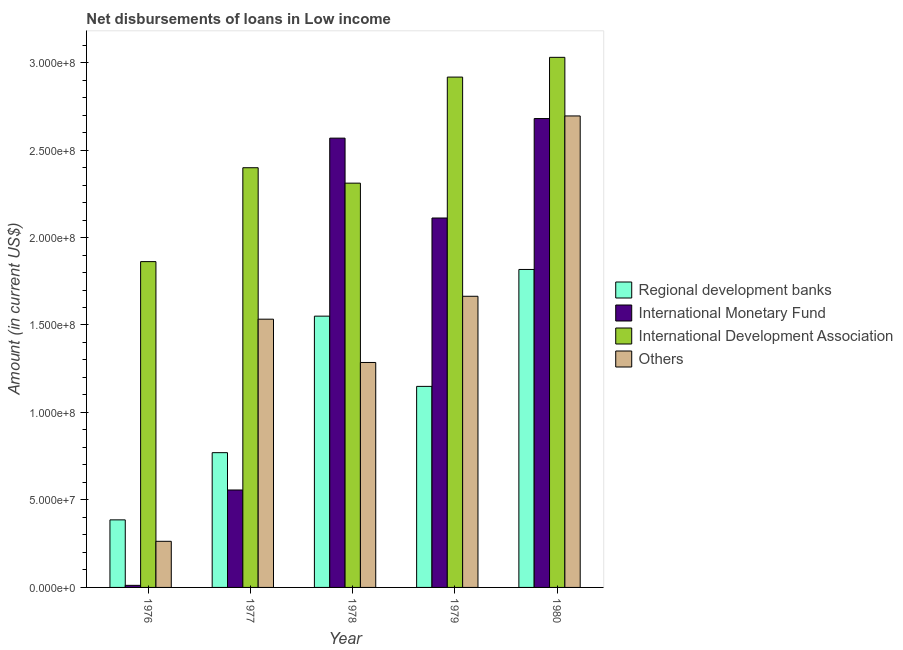How many different coloured bars are there?
Provide a short and direct response. 4. How many groups of bars are there?
Provide a short and direct response. 5. How many bars are there on the 3rd tick from the left?
Provide a short and direct response. 4. What is the label of the 3rd group of bars from the left?
Your answer should be compact. 1978. What is the amount of loan disimbursed by regional development banks in 1980?
Your answer should be compact. 1.82e+08. Across all years, what is the maximum amount of loan disimbursed by other organisations?
Give a very brief answer. 2.69e+08. Across all years, what is the minimum amount of loan disimbursed by international monetary fund?
Give a very brief answer. 1.18e+06. In which year was the amount of loan disimbursed by other organisations minimum?
Provide a succinct answer. 1976. What is the total amount of loan disimbursed by international development association in the graph?
Ensure brevity in your answer.  1.25e+09. What is the difference between the amount of loan disimbursed by international development association in 1976 and that in 1980?
Make the answer very short. -1.17e+08. What is the difference between the amount of loan disimbursed by other organisations in 1976 and the amount of loan disimbursed by international development association in 1977?
Keep it short and to the point. -1.27e+08. What is the average amount of loan disimbursed by regional development banks per year?
Provide a short and direct response. 1.13e+08. What is the ratio of the amount of loan disimbursed by international monetary fund in 1976 to that in 1977?
Give a very brief answer. 0.02. Is the amount of loan disimbursed by other organisations in 1976 less than that in 1979?
Keep it short and to the point. Yes. Is the difference between the amount of loan disimbursed by international monetary fund in 1979 and 1980 greater than the difference between the amount of loan disimbursed by other organisations in 1979 and 1980?
Provide a short and direct response. No. What is the difference between the highest and the second highest amount of loan disimbursed by other organisations?
Provide a succinct answer. 1.03e+08. What is the difference between the highest and the lowest amount of loan disimbursed by other organisations?
Make the answer very short. 2.43e+08. Is the sum of the amount of loan disimbursed by international development association in 1979 and 1980 greater than the maximum amount of loan disimbursed by other organisations across all years?
Your answer should be compact. Yes. What does the 3rd bar from the left in 1976 represents?
Your answer should be compact. International Development Association. What does the 4th bar from the right in 1976 represents?
Your answer should be very brief. Regional development banks. Is it the case that in every year, the sum of the amount of loan disimbursed by regional development banks and amount of loan disimbursed by international monetary fund is greater than the amount of loan disimbursed by international development association?
Make the answer very short. No. How many bars are there?
Provide a short and direct response. 20. Are all the bars in the graph horizontal?
Provide a succinct answer. No. Are the values on the major ticks of Y-axis written in scientific E-notation?
Provide a short and direct response. Yes. How many legend labels are there?
Keep it short and to the point. 4. How are the legend labels stacked?
Make the answer very short. Vertical. What is the title of the graph?
Your answer should be compact. Net disbursements of loans in Low income. Does "Gender equality" appear as one of the legend labels in the graph?
Your answer should be compact. No. What is the label or title of the X-axis?
Your answer should be compact. Year. What is the label or title of the Y-axis?
Your answer should be compact. Amount (in current US$). What is the Amount (in current US$) of Regional development banks in 1976?
Your answer should be compact. 3.86e+07. What is the Amount (in current US$) in International Monetary Fund in 1976?
Offer a terse response. 1.18e+06. What is the Amount (in current US$) of International Development Association in 1976?
Offer a very short reply. 1.86e+08. What is the Amount (in current US$) of Others in 1976?
Provide a short and direct response. 2.64e+07. What is the Amount (in current US$) of Regional development banks in 1977?
Ensure brevity in your answer.  7.70e+07. What is the Amount (in current US$) in International Monetary Fund in 1977?
Your answer should be compact. 5.57e+07. What is the Amount (in current US$) of International Development Association in 1977?
Give a very brief answer. 2.40e+08. What is the Amount (in current US$) in Others in 1977?
Make the answer very short. 1.53e+08. What is the Amount (in current US$) of Regional development banks in 1978?
Provide a short and direct response. 1.55e+08. What is the Amount (in current US$) in International Monetary Fund in 1978?
Offer a very short reply. 2.57e+08. What is the Amount (in current US$) in International Development Association in 1978?
Offer a terse response. 2.31e+08. What is the Amount (in current US$) of Others in 1978?
Provide a succinct answer. 1.29e+08. What is the Amount (in current US$) in Regional development banks in 1979?
Your answer should be very brief. 1.15e+08. What is the Amount (in current US$) of International Monetary Fund in 1979?
Your answer should be compact. 2.11e+08. What is the Amount (in current US$) of International Development Association in 1979?
Ensure brevity in your answer.  2.92e+08. What is the Amount (in current US$) in Others in 1979?
Your response must be concise. 1.66e+08. What is the Amount (in current US$) in Regional development banks in 1980?
Your answer should be compact. 1.82e+08. What is the Amount (in current US$) in International Monetary Fund in 1980?
Ensure brevity in your answer.  2.68e+08. What is the Amount (in current US$) in International Development Association in 1980?
Ensure brevity in your answer.  3.03e+08. What is the Amount (in current US$) in Others in 1980?
Offer a terse response. 2.69e+08. Across all years, what is the maximum Amount (in current US$) of Regional development banks?
Keep it short and to the point. 1.82e+08. Across all years, what is the maximum Amount (in current US$) of International Monetary Fund?
Give a very brief answer. 2.68e+08. Across all years, what is the maximum Amount (in current US$) in International Development Association?
Offer a terse response. 3.03e+08. Across all years, what is the maximum Amount (in current US$) in Others?
Your answer should be compact. 2.69e+08. Across all years, what is the minimum Amount (in current US$) of Regional development banks?
Offer a very short reply. 3.86e+07. Across all years, what is the minimum Amount (in current US$) of International Monetary Fund?
Provide a succinct answer. 1.18e+06. Across all years, what is the minimum Amount (in current US$) in International Development Association?
Make the answer very short. 1.86e+08. Across all years, what is the minimum Amount (in current US$) in Others?
Provide a short and direct response. 2.64e+07. What is the total Amount (in current US$) in Regional development banks in the graph?
Provide a short and direct response. 5.67e+08. What is the total Amount (in current US$) of International Monetary Fund in the graph?
Make the answer very short. 7.93e+08. What is the total Amount (in current US$) of International Development Association in the graph?
Offer a terse response. 1.25e+09. What is the total Amount (in current US$) in Others in the graph?
Make the answer very short. 7.44e+08. What is the difference between the Amount (in current US$) of Regional development banks in 1976 and that in 1977?
Make the answer very short. -3.84e+07. What is the difference between the Amount (in current US$) in International Monetary Fund in 1976 and that in 1977?
Ensure brevity in your answer.  -5.45e+07. What is the difference between the Amount (in current US$) in International Development Association in 1976 and that in 1977?
Ensure brevity in your answer.  -5.37e+07. What is the difference between the Amount (in current US$) in Others in 1976 and that in 1977?
Provide a succinct answer. -1.27e+08. What is the difference between the Amount (in current US$) in Regional development banks in 1976 and that in 1978?
Provide a short and direct response. -1.16e+08. What is the difference between the Amount (in current US$) of International Monetary Fund in 1976 and that in 1978?
Your answer should be compact. -2.56e+08. What is the difference between the Amount (in current US$) in International Development Association in 1976 and that in 1978?
Keep it short and to the point. -4.48e+07. What is the difference between the Amount (in current US$) of Others in 1976 and that in 1978?
Offer a terse response. -1.02e+08. What is the difference between the Amount (in current US$) in Regional development banks in 1976 and that in 1979?
Provide a short and direct response. -7.63e+07. What is the difference between the Amount (in current US$) in International Monetary Fund in 1976 and that in 1979?
Offer a very short reply. -2.10e+08. What is the difference between the Amount (in current US$) of International Development Association in 1976 and that in 1979?
Offer a terse response. -1.05e+08. What is the difference between the Amount (in current US$) of Others in 1976 and that in 1979?
Ensure brevity in your answer.  -1.40e+08. What is the difference between the Amount (in current US$) in Regional development banks in 1976 and that in 1980?
Ensure brevity in your answer.  -1.43e+08. What is the difference between the Amount (in current US$) of International Monetary Fund in 1976 and that in 1980?
Your answer should be compact. -2.67e+08. What is the difference between the Amount (in current US$) in International Development Association in 1976 and that in 1980?
Keep it short and to the point. -1.17e+08. What is the difference between the Amount (in current US$) in Others in 1976 and that in 1980?
Your response must be concise. -2.43e+08. What is the difference between the Amount (in current US$) of Regional development banks in 1977 and that in 1978?
Ensure brevity in your answer.  -7.80e+07. What is the difference between the Amount (in current US$) in International Monetary Fund in 1977 and that in 1978?
Provide a short and direct response. -2.01e+08. What is the difference between the Amount (in current US$) of International Development Association in 1977 and that in 1978?
Provide a short and direct response. 8.82e+06. What is the difference between the Amount (in current US$) in Others in 1977 and that in 1978?
Offer a very short reply. 2.47e+07. What is the difference between the Amount (in current US$) in Regional development banks in 1977 and that in 1979?
Give a very brief answer. -3.79e+07. What is the difference between the Amount (in current US$) in International Monetary Fund in 1977 and that in 1979?
Offer a very short reply. -1.55e+08. What is the difference between the Amount (in current US$) in International Development Association in 1977 and that in 1979?
Give a very brief answer. -5.18e+07. What is the difference between the Amount (in current US$) of Others in 1977 and that in 1979?
Your answer should be very brief. -1.31e+07. What is the difference between the Amount (in current US$) in Regional development banks in 1977 and that in 1980?
Offer a very short reply. -1.05e+08. What is the difference between the Amount (in current US$) of International Monetary Fund in 1977 and that in 1980?
Provide a succinct answer. -2.12e+08. What is the difference between the Amount (in current US$) of International Development Association in 1977 and that in 1980?
Offer a very short reply. -6.31e+07. What is the difference between the Amount (in current US$) in Others in 1977 and that in 1980?
Make the answer very short. -1.16e+08. What is the difference between the Amount (in current US$) of Regional development banks in 1978 and that in 1979?
Keep it short and to the point. 4.02e+07. What is the difference between the Amount (in current US$) in International Monetary Fund in 1978 and that in 1979?
Provide a succinct answer. 4.57e+07. What is the difference between the Amount (in current US$) in International Development Association in 1978 and that in 1979?
Give a very brief answer. -6.06e+07. What is the difference between the Amount (in current US$) in Others in 1978 and that in 1979?
Provide a succinct answer. -3.78e+07. What is the difference between the Amount (in current US$) in Regional development banks in 1978 and that in 1980?
Provide a succinct answer. -2.67e+07. What is the difference between the Amount (in current US$) of International Monetary Fund in 1978 and that in 1980?
Provide a short and direct response. -1.12e+07. What is the difference between the Amount (in current US$) in International Development Association in 1978 and that in 1980?
Make the answer very short. -7.19e+07. What is the difference between the Amount (in current US$) of Others in 1978 and that in 1980?
Offer a very short reply. -1.41e+08. What is the difference between the Amount (in current US$) of Regional development banks in 1979 and that in 1980?
Provide a succinct answer. -6.68e+07. What is the difference between the Amount (in current US$) in International Monetary Fund in 1979 and that in 1980?
Give a very brief answer. -5.68e+07. What is the difference between the Amount (in current US$) in International Development Association in 1979 and that in 1980?
Ensure brevity in your answer.  -1.13e+07. What is the difference between the Amount (in current US$) of Others in 1979 and that in 1980?
Your answer should be compact. -1.03e+08. What is the difference between the Amount (in current US$) in Regional development banks in 1976 and the Amount (in current US$) in International Monetary Fund in 1977?
Your answer should be very brief. -1.71e+07. What is the difference between the Amount (in current US$) in Regional development banks in 1976 and the Amount (in current US$) in International Development Association in 1977?
Provide a short and direct response. -2.01e+08. What is the difference between the Amount (in current US$) of Regional development banks in 1976 and the Amount (in current US$) of Others in 1977?
Provide a short and direct response. -1.15e+08. What is the difference between the Amount (in current US$) of International Monetary Fund in 1976 and the Amount (in current US$) of International Development Association in 1977?
Your response must be concise. -2.39e+08. What is the difference between the Amount (in current US$) of International Monetary Fund in 1976 and the Amount (in current US$) of Others in 1977?
Provide a succinct answer. -1.52e+08. What is the difference between the Amount (in current US$) in International Development Association in 1976 and the Amount (in current US$) in Others in 1977?
Keep it short and to the point. 3.29e+07. What is the difference between the Amount (in current US$) of Regional development banks in 1976 and the Amount (in current US$) of International Monetary Fund in 1978?
Offer a terse response. -2.18e+08. What is the difference between the Amount (in current US$) of Regional development banks in 1976 and the Amount (in current US$) of International Development Association in 1978?
Ensure brevity in your answer.  -1.92e+08. What is the difference between the Amount (in current US$) of Regional development banks in 1976 and the Amount (in current US$) of Others in 1978?
Offer a terse response. -9.00e+07. What is the difference between the Amount (in current US$) of International Monetary Fund in 1976 and the Amount (in current US$) of International Development Association in 1978?
Provide a short and direct response. -2.30e+08. What is the difference between the Amount (in current US$) of International Monetary Fund in 1976 and the Amount (in current US$) of Others in 1978?
Give a very brief answer. -1.27e+08. What is the difference between the Amount (in current US$) in International Development Association in 1976 and the Amount (in current US$) in Others in 1978?
Your answer should be compact. 5.76e+07. What is the difference between the Amount (in current US$) in Regional development banks in 1976 and the Amount (in current US$) in International Monetary Fund in 1979?
Your answer should be compact. -1.73e+08. What is the difference between the Amount (in current US$) in Regional development banks in 1976 and the Amount (in current US$) in International Development Association in 1979?
Provide a succinct answer. -2.53e+08. What is the difference between the Amount (in current US$) in Regional development banks in 1976 and the Amount (in current US$) in Others in 1979?
Keep it short and to the point. -1.28e+08. What is the difference between the Amount (in current US$) of International Monetary Fund in 1976 and the Amount (in current US$) of International Development Association in 1979?
Your answer should be compact. -2.91e+08. What is the difference between the Amount (in current US$) in International Monetary Fund in 1976 and the Amount (in current US$) in Others in 1979?
Offer a very short reply. -1.65e+08. What is the difference between the Amount (in current US$) in International Development Association in 1976 and the Amount (in current US$) in Others in 1979?
Provide a short and direct response. 1.98e+07. What is the difference between the Amount (in current US$) in Regional development banks in 1976 and the Amount (in current US$) in International Monetary Fund in 1980?
Provide a succinct answer. -2.29e+08. What is the difference between the Amount (in current US$) of Regional development banks in 1976 and the Amount (in current US$) of International Development Association in 1980?
Provide a short and direct response. -2.64e+08. What is the difference between the Amount (in current US$) of Regional development banks in 1976 and the Amount (in current US$) of Others in 1980?
Your response must be concise. -2.31e+08. What is the difference between the Amount (in current US$) in International Monetary Fund in 1976 and the Amount (in current US$) in International Development Association in 1980?
Keep it short and to the point. -3.02e+08. What is the difference between the Amount (in current US$) of International Monetary Fund in 1976 and the Amount (in current US$) of Others in 1980?
Your response must be concise. -2.68e+08. What is the difference between the Amount (in current US$) of International Development Association in 1976 and the Amount (in current US$) of Others in 1980?
Your response must be concise. -8.33e+07. What is the difference between the Amount (in current US$) in Regional development banks in 1977 and the Amount (in current US$) in International Monetary Fund in 1978?
Offer a very short reply. -1.80e+08. What is the difference between the Amount (in current US$) in Regional development banks in 1977 and the Amount (in current US$) in International Development Association in 1978?
Offer a very short reply. -1.54e+08. What is the difference between the Amount (in current US$) of Regional development banks in 1977 and the Amount (in current US$) of Others in 1978?
Provide a short and direct response. -5.16e+07. What is the difference between the Amount (in current US$) in International Monetary Fund in 1977 and the Amount (in current US$) in International Development Association in 1978?
Offer a terse response. -1.75e+08. What is the difference between the Amount (in current US$) of International Monetary Fund in 1977 and the Amount (in current US$) of Others in 1978?
Your answer should be very brief. -7.29e+07. What is the difference between the Amount (in current US$) of International Development Association in 1977 and the Amount (in current US$) of Others in 1978?
Offer a very short reply. 1.11e+08. What is the difference between the Amount (in current US$) of Regional development banks in 1977 and the Amount (in current US$) of International Monetary Fund in 1979?
Keep it short and to the point. -1.34e+08. What is the difference between the Amount (in current US$) in Regional development banks in 1977 and the Amount (in current US$) in International Development Association in 1979?
Your response must be concise. -2.15e+08. What is the difference between the Amount (in current US$) of Regional development banks in 1977 and the Amount (in current US$) of Others in 1979?
Your response must be concise. -8.94e+07. What is the difference between the Amount (in current US$) of International Monetary Fund in 1977 and the Amount (in current US$) of International Development Association in 1979?
Offer a terse response. -2.36e+08. What is the difference between the Amount (in current US$) of International Monetary Fund in 1977 and the Amount (in current US$) of Others in 1979?
Your answer should be very brief. -1.11e+08. What is the difference between the Amount (in current US$) of International Development Association in 1977 and the Amount (in current US$) of Others in 1979?
Provide a succinct answer. 7.35e+07. What is the difference between the Amount (in current US$) of Regional development banks in 1977 and the Amount (in current US$) of International Monetary Fund in 1980?
Provide a short and direct response. -1.91e+08. What is the difference between the Amount (in current US$) in Regional development banks in 1977 and the Amount (in current US$) in International Development Association in 1980?
Your answer should be very brief. -2.26e+08. What is the difference between the Amount (in current US$) in Regional development banks in 1977 and the Amount (in current US$) in Others in 1980?
Provide a short and direct response. -1.92e+08. What is the difference between the Amount (in current US$) of International Monetary Fund in 1977 and the Amount (in current US$) of International Development Association in 1980?
Offer a terse response. -2.47e+08. What is the difference between the Amount (in current US$) in International Monetary Fund in 1977 and the Amount (in current US$) in Others in 1980?
Your answer should be compact. -2.14e+08. What is the difference between the Amount (in current US$) of International Development Association in 1977 and the Amount (in current US$) of Others in 1980?
Your response must be concise. -2.96e+07. What is the difference between the Amount (in current US$) in Regional development banks in 1978 and the Amount (in current US$) in International Monetary Fund in 1979?
Keep it short and to the point. -5.61e+07. What is the difference between the Amount (in current US$) in Regional development banks in 1978 and the Amount (in current US$) in International Development Association in 1979?
Keep it short and to the point. -1.37e+08. What is the difference between the Amount (in current US$) of Regional development banks in 1978 and the Amount (in current US$) of Others in 1979?
Provide a succinct answer. -1.14e+07. What is the difference between the Amount (in current US$) in International Monetary Fund in 1978 and the Amount (in current US$) in International Development Association in 1979?
Ensure brevity in your answer.  -3.49e+07. What is the difference between the Amount (in current US$) in International Monetary Fund in 1978 and the Amount (in current US$) in Others in 1979?
Give a very brief answer. 9.04e+07. What is the difference between the Amount (in current US$) in International Development Association in 1978 and the Amount (in current US$) in Others in 1979?
Keep it short and to the point. 6.47e+07. What is the difference between the Amount (in current US$) of Regional development banks in 1978 and the Amount (in current US$) of International Monetary Fund in 1980?
Offer a terse response. -1.13e+08. What is the difference between the Amount (in current US$) of Regional development banks in 1978 and the Amount (in current US$) of International Development Association in 1980?
Your response must be concise. -1.48e+08. What is the difference between the Amount (in current US$) in Regional development banks in 1978 and the Amount (in current US$) in Others in 1980?
Offer a very short reply. -1.14e+08. What is the difference between the Amount (in current US$) in International Monetary Fund in 1978 and the Amount (in current US$) in International Development Association in 1980?
Your answer should be very brief. -4.62e+07. What is the difference between the Amount (in current US$) in International Monetary Fund in 1978 and the Amount (in current US$) in Others in 1980?
Offer a terse response. -1.27e+07. What is the difference between the Amount (in current US$) in International Development Association in 1978 and the Amount (in current US$) in Others in 1980?
Your response must be concise. -3.84e+07. What is the difference between the Amount (in current US$) of Regional development banks in 1979 and the Amount (in current US$) of International Monetary Fund in 1980?
Make the answer very short. -1.53e+08. What is the difference between the Amount (in current US$) in Regional development banks in 1979 and the Amount (in current US$) in International Development Association in 1980?
Make the answer very short. -1.88e+08. What is the difference between the Amount (in current US$) in Regional development banks in 1979 and the Amount (in current US$) in Others in 1980?
Your response must be concise. -1.55e+08. What is the difference between the Amount (in current US$) in International Monetary Fund in 1979 and the Amount (in current US$) in International Development Association in 1980?
Make the answer very short. -9.18e+07. What is the difference between the Amount (in current US$) in International Monetary Fund in 1979 and the Amount (in current US$) in Others in 1980?
Offer a very short reply. -5.83e+07. What is the difference between the Amount (in current US$) in International Development Association in 1979 and the Amount (in current US$) in Others in 1980?
Offer a terse response. 2.22e+07. What is the average Amount (in current US$) in Regional development banks per year?
Give a very brief answer. 1.13e+08. What is the average Amount (in current US$) in International Monetary Fund per year?
Keep it short and to the point. 1.59e+08. What is the average Amount (in current US$) in International Development Association per year?
Your answer should be very brief. 2.50e+08. What is the average Amount (in current US$) in Others per year?
Provide a succinct answer. 1.49e+08. In the year 1976, what is the difference between the Amount (in current US$) of Regional development banks and Amount (in current US$) of International Monetary Fund?
Offer a terse response. 3.74e+07. In the year 1976, what is the difference between the Amount (in current US$) of Regional development banks and Amount (in current US$) of International Development Association?
Give a very brief answer. -1.48e+08. In the year 1976, what is the difference between the Amount (in current US$) in Regional development banks and Amount (in current US$) in Others?
Your answer should be very brief. 1.23e+07. In the year 1976, what is the difference between the Amount (in current US$) in International Monetary Fund and Amount (in current US$) in International Development Association?
Your response must be concise. -1.85e+08. In the year 1976, what is the difference between the Amount (in current US$) in International Monetary Fund and Amount (in current US$) in Others?
Make the answer very short. -2.52e+07. In the year 1976, what is the difference between the Amount (in current US$) of International Development Association and Amount (in current US$) of Others?
Offer a very short reply. 1.60e+08. In the year 1977, what is the difference between the Amount (in current US$) in Regional development banks and Amount (in current US$) in International Monetary Fund?
Offer a very short reply. 2.13e+07. In the year 1977, what is the difference between the Amount (in current US$) of Regional development banks and Amount (in current US$) of International Development Association?
Provide a succinct answer. -1.63e+08. In the year 1977, what is the difference between the Amount (in current US$) of Regional development banks and Amount (in current US$) of Others?
Provide a short and direct response. -7.63e+07. In the year 1977, what is the difference between the Amount (in current US$) in International Monetary Fund and Amount (in current US$) in International Development Association?
Keep it short and to the point. -1.84e+08. In the year 1977, what is the difference between the Amount (in current US$) of International Monetary Fund and Amount (in current US$) of Others?
Give a very brief answer. -9.76e+07. In the year 1977, what is the difference between the Amount (in current US$) of International Development Association and Amount (in current US$) of Others?
Provide a short and direct response. 8.66e+07. In the year 1978, what is the difference between the Amount (in current US$) in Regional development banks and Amount (in current US$) in International Monetary Fund?
Your answer should be compact. -1.02e+08. In the year 1978, what is the difference between the Amount (in current US$) of Regional development banks and Amount (in current US$) of International Development Association?
Keep it short and to the point. -7.60e+07. In the year 1978, what is the difference between the Amount (in current US$) of Regional development banks and Amount (in current US$) of Others?
Ensure brevity in your answer.  2.65e+07. In the year 1978, what is the difference between the Amount (in current US$) of International Monetary Fund and Amount (in current US$) of International Development Association?
Offer a very short reply. 2.57e+07. In the year 1978, what is the difference between the Amount (in current US$) of International Monetary Fund and Amount (in current US$) of Others?
Provide a succinct answer. 1.28e+08. In the year 1978, what is the difference between the Amount (in current US$) of International Development Association and Amount (in current US$) of Others?
Your response must be concise. 1.02e+08. In the year 1979, what is the difference between the Amount (in current US$) of Regional development banks and Amount (in current US$) of International Monetary Fund?
Your answer should be compact. -9.62e+07. In the year 1979, what is the difference between the Amount (in current US$) in Regional development banks and Amount (in current US$) in International Development Association?
Offer a terse response. -1.77e+08. In the year 1979, what is the difference between the Amount (in current US$) of Regional development banks and Amount (in current US$) of Others?
Offer a terse response. -5.15e+07. In the year 1979, what is the difference between the Amount (in current US$) of International Monetary Fund and Amount (in current US$) of International Development Association?
Keep it short and to the point. -8.06e+07. In the year 1979, what is the difference between the Amount (in current US$) in International Monetary Fund and Amount (in current US$) in Others?
Keep it short and to the point. 4.47e+07. In the year 1979, what is the difference between the Amount (in current US$) in International Development Association and Amount (in current US$) in Others?
Provide a short and direct response. 1.25e+08. In the year 1980, what is the difference between the Amount (in current US$) in Regional development banks and Amount (in current US$) in International Monetary Fund?
Offer a terse response. -8.63e+07. In the year 1980, what is the difference between the Amount (in current US$) of Regional development banks and Amount (in current US$) of International Development Association?
Offer a very short reply. -1.21e+08. In the year 1980, what is the difference between the Amount (in current US$) of Regional development banks and Amount (in current US$) of Others?
Offer a terse response. -8.78e+07. In the year 1980, what is the difference between the Amount (in current US$) of International Monetary Fund and Amount (in current US$) of International Development Association?
Keep it short and to the point. -3.50e+07. In the year 1980, what is the difference between the Amount (in current US$) of International Monetary Fund and Amount (in current US$) of Others?
Your response must be concise. -1.49e+06. In the year 1980, what is the difference between the Amount (in current US$) of International Development Association and Amount (in current US$) of Others?
Make the answer very short. 3.35e+07. What is the ratio of the Amount (in current US$) of Regional development banks in 1976 to that in 1977?
Provide a succinct answer. 0.5. What is the ratio of the Amount (in current US$) of International Monetary Fund in 1976 to that in 1977?
Provide a short and direct response. 0.02. What is the ratio of the Amount (in current US$) in International Development Association in 1976 to that in 1977?
Your answer should be very brief. 0.78. What is the ratio of the Amount (in current US$) in Others in 1976 to that in 1977?
Provide a short and direct response. 0.17. What is the ratio of the Amount (in current US$) in Regional development banks in 1976 to that in 1978?
Give a very brief answer. 0.25. What is the ratio of the Amount (in current US$) in International Monetary Fund in 1976 to that in 1978?
Your answer should be compact. 0. What is the ratio of the Amount (in current US$) in International Development Association in 1976 to that in 1978?
Give a very brief answer. 0.81. What is the ratio of the Amount (in current US$) of Others in 1976 to that in 1978?
Your answer should be compact. 0.2. What is the ratio of the Amount (in current US$) in Regional development banks in 1976 to that in 1979?
Give a very brief answer. 0.34. What is the ratio of the Amount (in current US$) of International Monetary Fund in 1976 to that in 1979?
Provide a succinct answer. 0.01. What is the ratio of the Amount (in current US$) of International Development Association in 1976 to that in 1979?
Offer a very short reply. 0.64. What is the ratio of the Amount (in current US$) in Others in 1976 to that in 1979?
Offer a very short reply. 0.16. What is the ratio of the Amount (in current US$) in Regional development banks in 1976 to that in 1980?
Your answer should be compact. 0.21. What is the ratio of the Amount (in current US$) of International Monetary Fund in 1976 to that in 1980?
Offer a terse response. 0. What is the ratio of the Amount (in current US$) of International Development Association in 1976 to that in 1980?
Give a very brief answer. 0.61. What is the ratio of the Amount (in current US$) in Others in 1976 to that in 1980?
Your answer should be compact. 0.1. What is the ratio of the Amount (in current US$) in Regional development banks in 1977 to that in 1978?
Your response must be concise. 0.5. What is the ratio of the Amount (in current US$) in International Monetary Fund in 1977 to that in 1978?
Offer a terse response. 0.22. What is the ratio of the Amount (in current US$) of International Development Association in 1977 to that in 1978?
Offer a very short reply. 1.04. What is the ratio of the Amount (in current US$) of Others in 1977 to that in 1978?
Give a very brief answer. 1.19. What is the ratio of the Amount (in current US$) of Regional development banks in 1977 to that in 1979?
Provide a succinct answer. 0.67. What is the ratio of the Amount (in current US$) in International Monetary Fund in 1977 to that in 1979?
Provide a succinct answer. 0.26. What is the ratio of the Amount (in current US$) of International Development Association in 1977 to that in 1979?
Make the answer very short. 0.82. What is the ratio of the Amount (in current US$) in Others in 1977 to that in 1979?
Provide a succinct answer. 0.92. What is the ratio of the Amount (in current US$) in Regional development banks in 1977 to that in 1980?
Make the answer very short. 0.42. What is the ratio of the Amount (in current US$) of International Monetary Fund in 1977 to that in 1980?
Give a very brief answer. 0.21. What is the ratio of the Amount (in current US$) of International Development Association in 1977 to that in 1980?
Your response must be concise. 0.79. What is the ratio of the Amount (in current US$) in Others in 1977 to that in 1980?
Your answer should be compact. 0.57. What is the ratio of the Amount (in current US$) of Regional development banks in 1978 to that in 1979?
Give a very brief answer. 1.35. What is the ratio of the Amount (in current US$) of International Monetary Fund in 1978 to that in 1979?
Provide a succinct answer. 1.22. What is the ratio of the Amount (in current US$) of International Development Association in 1978 to that in 1979?
Make the answer very short. 0.79. What is the ratio of the Amount (in current US$) in Others in 1978 to that in 1979?
Offer a very short reply. 0.77. What is the ratio of the Amount (in current US$) in Regional development banks in 1978 to that in 1980?
Give a very brief answer. 0.85. What is the ratio of the Amount (in current US$) in International Monetary Fund in 1978 to that in 1980?
Offer a very short reply. 0.96. What is the ratio of the Amount (in current US$) in International Development Association in 1978 to that in 1980?
Offer a very short reply. 0.76. What is the ratio of the Amount (in current US$) in Others in 1978 to that in 1980?
Your answer should be very brief. 0.48. What is the ratio of the Amount (in current US$) of Regional development banks in 1979 to that in 1980?
Provide a succinct answer. 0.63. What is the ratio of the Amount (in current US$) of International Monetary Fund in 1979 to that in 1980?
Keep it short and to the point. 0.79. What is the ratio of the Amount (in current US$) in International Development Association in 1979 to that in 1980?
Make the answer very short. 0.96. What is the ratio of the Amount (in current US$) in Others in 1979 to that in 1980?
Keep it short and to the point. 0.62. What is the difference between the highest and the second highest Amount (in current US$) in Regional development banks?
Your response must be concise. 2.67e+07. What is the difference between the highest and the second highest Amount (in current US$) in International Monetary Fund?
Keep it short and to the point. 1.12e+07. What is the difference between the highest and the second highest Amount (in current US$) of International Development Association?
Your answer should be compact. 1.13e+07. What is the difference between the highest and the second highest Amount (in current US$) of Others?
Keep it short and to the point. 1.03e+08. What is the difference between the highest and the lowest Amount (in current US$) in Regional development banks?
Make the answer very short. 1.43e+08. What is the difference between the highest and the lowest Amount (in current US$) in International Monetary Fund?
Make the answer very short. 2.67e+08. What is the difference between the highest and the lowest Amount (in current US$) in International Development Association?
Your answer should be very brief. 1.17e+08. What is the difference between the highest and the lowest Amount (in current US$) of Others?
Your answer should be very brief. 2.43e+08. 